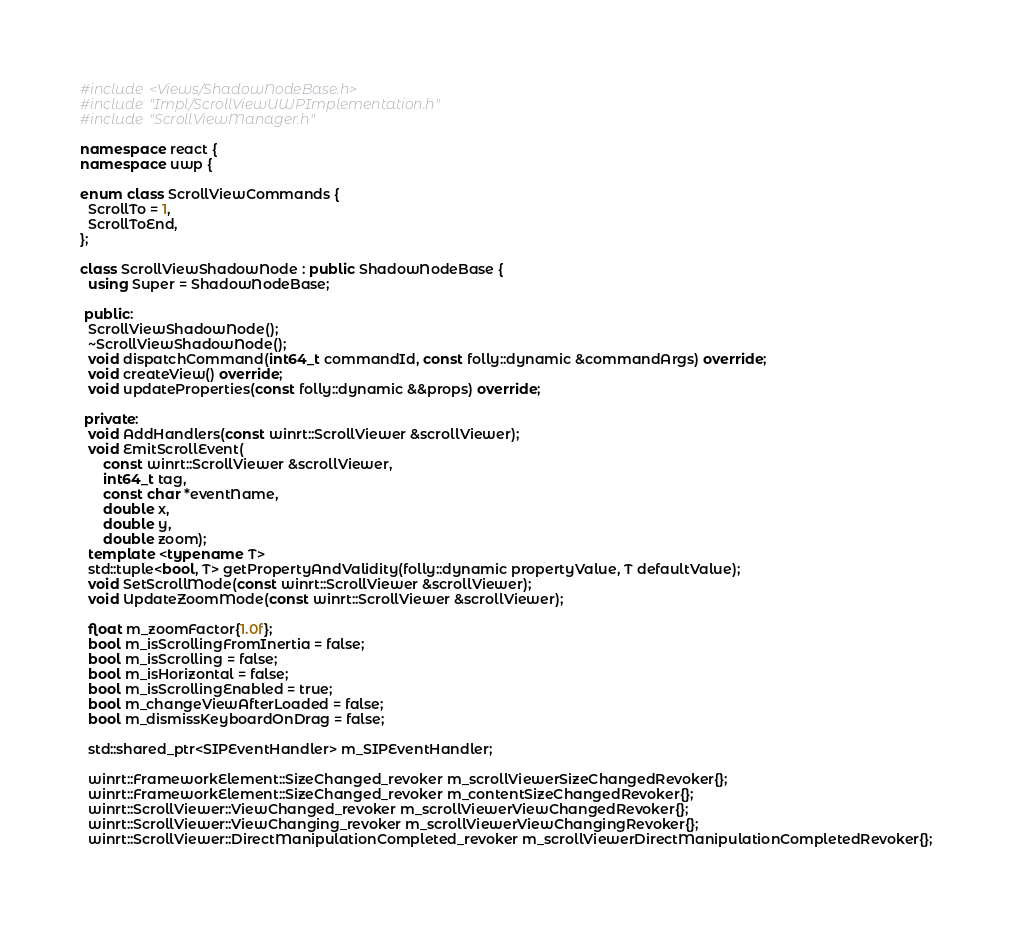<code> <loc_0><loc_0><loc_500><loc_500><_C++_>#include <Views/ShadowNodeBase.h>
#include "Impl/ScrollViewUWPImplementation.h"
#include "ScrollViewManager.h"

namespace react {
namespace uwp {

enum class ScrollViewCommands {
  ScrollTo = 1,
  ScrollToEnd,
};

class ScrollViewShadowNode : public ShadowNodeBase {
  using Super = ShadowNodeBase;

 public:
  ScrollViewShadowNode();
  ~ScrollViewShadowNode();
  void dispatchCommand(int64_t commandId, const folly::dynamic &commandArgs) override;
  void createView() override;
  void updateProperties(const folly::dynamic &&props) override;

 private:
  void AddHandlers(const winrt::ScrollViewer &scrollViewer);
  void EmitScrollEvent(
      const winrt::ScrollViewer &scrollViewer,
      int64_t tag,
      const char *eventName,
      double x,
      double y,
      double zoom);
  template <typename T>
  std::tuple<bool, T> getPropertyAndValidity(folly::dynamic propertyValue, T defaultValue);
  void SetScrollMode(const winrt::ScrollViewer &scrollViewer);
  void UpdateZoomMode(const winrt::ScrollViewer &scrollViewer);

  float m_zoomFactor{1.0f};
  bool m_isScrollingFromInertia = false;
  bool m_isScrolling = false;
  bool m_isHorizontal = false;
  bool m_isScrollingEnabled = true;
  bool m_changeViewAfterLoaded = false;
  bool m_dismissKeyboardOnDrag = false;

  std::shared_ptr<SIPEventHandler> m_SIPEventHandler;

  winrt::FrameworkElement::SizeChanged_revoker m_scrollViewerSizeChangedRevoker{};
  winrt::FrameworkElement::SizeChanged_revoker m_contentSizeChangedRevoker{};
  winrt::ScrollViewer::ViewChanged_revoker m_scrollViewerViewChangedRevoker{};
  winrt::ScrollViewer::ViewChanging_revoker m_scrollViewerViewChangingRevoker{};
  winrt::ScrollViewer::DirectManipulationCompleted_revoker m_scrollViewerDirectManipulationCompletedRevoker{};</code> 